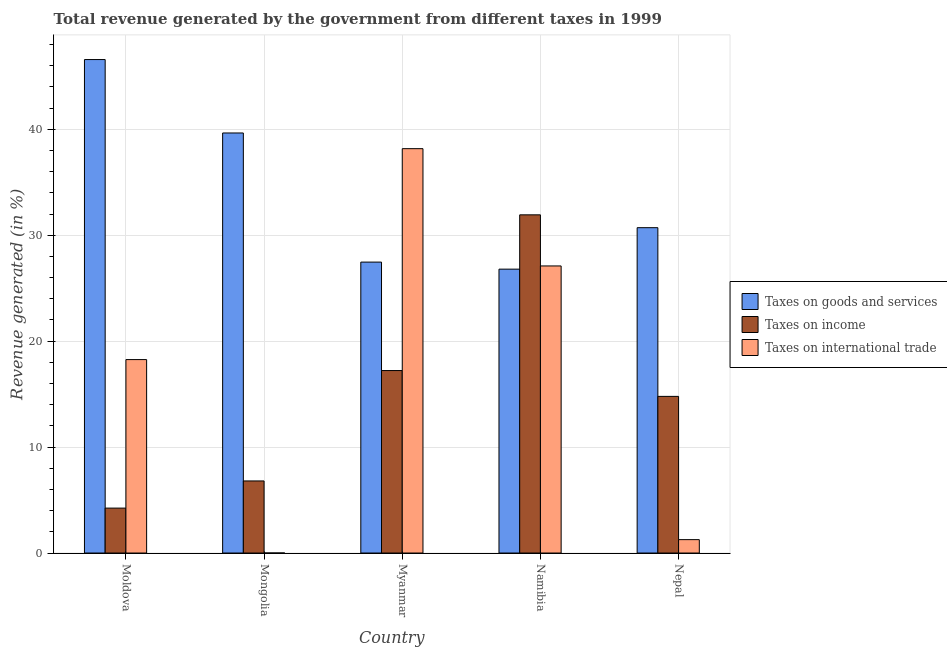How many different coloured bars are there?
Make the answer very short. 3. How many groups of bars are there?
Give a very brief answer. 5. How many bars are there on the 3rd tick from the left?
Your answer should be compact. 3. How many bars are there on the 2nd tick from the right?
Provide a short and direct response. 3. What is the label of the 1st group of bars from the left?
Provide a short and direct response. Moldova. In how many cases, is the number of bars for a given country not equal to the number of legend labels?
Your answer should be very brief. 0. What is the percentage of revenue generated by tax on international trade in Namibia?
Your response must be concise. 27.1. Across all countries, what is the maximum percentage of revenue generated by taxes on goods and services?
Provide a succinct answer. 46.58. Across all countries, what is the minimum percentage of revenue generated by tax on international trade?
Your response must be concise. 0. In which country was the percentage of revenue generated by taxes on goods and services maximum?
Give a very brief answer. Moldova. In which country was the percentage of revenue generated by tax on international trade minimum?
Provide a short and direct response. Mongolia. What is the total percentage of revenue generated by taxes on goods and services in the graph?
Provide a succinct answer. 171.19. What is the difference between the percentage of revenue generated by taxes on income in Mongolia and that in Myanmar?
Offer a very short reply. -10.42. What is the difference between the percentage of revenue generated by taxes on income in Moldova and the percentage of revenue generated by taxes on goods and services in Mongolia?
Give a very brief answer. -35.41. What is the average percentage of revenue generated by tax on international trade per country?
Offer a terse response. 16.96. What is the difference between the percentage of revenue generated by tax on international trade and percentage of revenue generated by taxes on income in Namibia?
Keep it short and to the point. -4.82. What is the ratio of the percentage of revenue generated by tax on international trade in Mongolia to that in Nepal?
Your response must be concise. 0. Is the percentage of revenue generated by tax on international trade in Namibia less than that in Nepal?
Your answer should be compact. No. What is the difference between the highest and the second highest percentage of revenue generated by tax on international trade?
Your answer should be compact. 11.07. What is the difference between the highest and the lowest percentage of revenue generated by taxes on income?
Offer a very short reply. 27.68. Is the sum of the percentage of revenue generated by taxes on income in Myanmar and Namibia greater than the maximum percentage of revenue generated by tax on international trade across all countries?
Ensure brevity in your answer.  Yes. What does the 1st bar from the left in Moldova represents?
Offer a terse response. Taxes on goods and services. What does the 2nd bar from the right in Myanmar represents?
Your answer should be very brief. Taxes on income. Is it the case that in every country, the sum of the percentage of revenue generated by taxes on goods and services and percentage of revenue generated by taxes on income is greater than the percentage of revenue generated by tax on international trade?
Ensure brevity in your answer.  Yes. How many countries are there in the graph?
Ensure brevity in your answer.  5. What is the difference between two consecutive major ticks on the Y-axis?
Provide a short and direct response. 10. Does the graph contain grids?
Your response must be concise. Yes. What is the title of the graph?
Keep it short and to the point. Total revenue generated by the government from different taxes in 1999. Does "Food" appear as one of the legend labels in the graph?
Provide a succinct answer. No. What is the label or title of the Y-axis?
Give a very brief answer. Revenue generated (in %). What is the Revenue generated (in %) of Taxes on goods and services in Moldova?
Make the answer very short. 46.58. What is the Revenue generated (in %) in Taxes on income in Moldova?
Offer a very short reply. 4.24. What is the Revenue generated (in %) in Taxes on international trade in Moldova?
Offer a very short reply. 18.26. What is the Revenue generated (in %) in Taxes on goods and services in Mongolia?
Provide a succinct answer. 39.65. What is the Revenue generated (in %) of Taxes on income in Mongolia?
Provide a succinct answer. 6.8. What is the Revenue generated (in %) in Taxes on international trade in Mongolia?
Provide a succinct answer. 0. What is the Revenue generated (in %) in Taxes on goods and services in Myanmar?
Keep it short and to the point. 27.46. What is the Revenue generated (in %) of Taxes on income in Myanmar?
Give a very brief answer. 17.22. What is the Revenue generated (in %) in Taxes on international trade in Myanmar?
Your response must be concise. 38.17. What is the Revenue generated (in %) of Taxes on goods and services in Namibia?
Make the answer very short. 26.8. What is the Revenue generated (in %) of Taxes on income in Namibia?
Offer a very short reply. 31.92. What is the Revenue generated (in %) in Taxes on international trade in Namibia?
Offer a terse response. 27.1. What is the Revenue generated (in %) in Taxes on goods and services in Nepal?
Make the answer very short. 30.71. What is the Revenue generated (in %) of Taxes on income in Nepal?
Provide a succinct answer. 14.79. What is the Revenue generated (in %) of Taxes on international trade in Nepal?
Make the answer very short. 1.26. Across all countries, what is the maximum Revenue generated (in %) of Taxes on goods and services?
Your response must be concise. 46.58. Across all countries, what is the maximum Revenue generated (in %) in Taxes on income?
Your answer should be very brief. 31.92. Across all countries, what is the maximum Revenue generated (in %) in Taxes on international trade?
Your answer should be very brief. 38.17. Across all countries, what is the minimum Revenue generated (in %) of Taxes on goods and services?
Keep it short and to the point. 26.8. Across all countries, what is the minimum Revenue generated (in %) of Taxes on income?
Offer a terse response. 4.24. Across all countries, what is the minimum Revenue generated (in %) in Taxes on international trade?
Provide a succinct answer. 0. What is the total Revenue generated (in %) of Taxes on goods and services in the graph?
Your answer should be compact. 171.19. What is the total Revenue generated (in %) in Taxes on income in the graph?
Offer a very short reply. 74.98. What is the total Revenue generated (in %) in Taxes on international trade in the graph?
Your answer should be compact. 84.79. What is the difference between the Revenue generated (in %) of Taxes on goods and services in Moldova and that in Mongolia?
Offer a terse response. 6.93. What is the difference between the Revenue generated (in %) of Taxes on income in Moldova and that in Mongolia?
Your response must be concise. -2.56. What is the difference between the Revenue generated (in %) of Taxes on international trade in Moldova and that in Mongolia?
Ensure brevity in your answer.  18.26. What is the difference between the Revenue generated (in %) in Taxes on goods and services in Moldova and that in Myanmar?
Provide a succinct answer. 19.12. What is the difference between the Revenue generated (in %) in Taxes on income in Moldova and that in Myanmar?
Offer a very short reply. -12.98. What is the difference between the Revenue generated (in %) in Taxes on international trade in Moldova and that in Myanmar?
Your response must be concise. -19.91. What is the difference between the Revenue generated (in %) in Taxes on goods and services in Moldova and that in Namibia?
Your answer should be compact. 19.78. What is the difference between the Revenue generated (in %) of Taxes on income in Moldova and that in Namibia?
Offer a terse response. -27.68. What is the difference between the Revenue generated (in %) of Taxes on international trade in Moldova and that in Namibia?
Your answer should be compact. -8.84. What is the difference between the Revenue generated (in %) of Taxes on goods and services in Moldova and that in Nepal?
Make the answer very short. 15.87. What is the difference between the Revenue generated (in %) in Taxes on income in Moldova and that in Nepal?
Your response must be concise. -10.55. What is the difference between the Revenue generated (in %) in Taxes on international trade in Moldova and that in Nepal?
Your answer should be compact. 16.99. What is the difference between the Revenue generated (in %) of Taxes on goods and services in Mongolia and that in Myanmar?
Offer a terse response. 12.19. What is the difference between the Revenue generated (in %) of Taxes on income in Mongolia and that in Myanmar?
Offer a terse response. -10.42. What is the difference between the Revenue generated (in %) in Taxes on international trade in Mongolia and that in Myanmar?
Provide a short and direct response. -38.17. What is the difference between the Revenue generated (in %) of Taxes on goods and services in Mongolia and that in Namibia?
Offer a very short reply. 12.85. What is the difference between the Revenue generated (in %) in Taxes on income in Mongolia and that in Namibia?
Keep it short and to the point. -25.12. What is the difference between the Revenue generated (in %) of Taxes on international trade in Mongolia and that in Namibia?
Your response must be concise. -27.1. What is the difference between the Revenue generated (in %) in Taxes on goods and services in Mongolia and that in Nepal?
Give a very brief answer. 8.94. What is the difference between the Revenue generated (in %) in Taxes on income in Mongolia and that in Nepal?
Your answer should be compact. -7.98. What is the difference between the Revenue generated (in %) of Taxes on international trade in Mongolia and that in Nepal?
Your response must be concise. -1.26. What is the difference between the Revenue generated (in %) in Taxes on goods and services in Myanmar and that in Namibia?
Offer a very short reply. 0.66. What is the difference between the Revenue generated (in %) of Taxes on income in Myanmar and that in Namibia?
Offer a very short reply. -14.7. What is the difference between the Revenue generated (in %) in Taxes on international trade in Myanmar and that in Namibia?
Your answer should be compact. 11.07. What is the difference between the Revenue generated (in %) of Taxes on goods and services in Myanmar and that in Nepal?
Your answer should be very brief. -3.25. What is the difference between the Revenue generated (in %) of Taxes on income in Myanmar and that in Nepal?
Keep it short and to the point. 2.44. What is the difference between the Revenue generated (in %) in Taxes on international trade in Myanmar and that in Nepal?
Your answer should be very brief. 36.9. What is the difference between the Revenue generated (in %) of Taxes on goods and services in Namibia and that in Nepal?
Keep it short and to the point. -3.91. What is the difference between the Revenue generated (in %) in Taxes on income in Namibia and that in Nepal?
Ensure brevity in your answer.  17.14. What is the difference between the Revenue generated (in %) in Taxes on international trade in Namibia and that in Nepal?
Your answer should be very brief. 25.83. What is the difference between the Revenue generated (in %) in Taxes on goods and services in Moldova and the Revenue generated (in %) in Taxes on income in Mongolia?
Offer a terse response. 39.78. What is the difference between the Revenue generated (in %) in Taxes on goods and services in Moldova and the Revenue generated (in %) in Taxes on international trade in Mongolia?
Offer a very short reply. 46.58. What is the difference between the Revenue generated (in %) in Taxes on income in Moldova and the Revenue generated (in %) in Taxes on international trade in Mongolia?
Your answer should be compact. 4.24. What is the difference between the Revenue generated (in %) of Taxes on goods and services in Moldova and the Revenue generated (in %) of Taxes on income in Myanmar?
Offer a terse response. 29.36. What is the difference between the Revenue generated (in %) of Taxes on goods and services in Moldova and the Revenue generated (in %) of Taxes on international trade in Myanmar?
Make the answer very short. 8.41. What is the difference between the Revenue generated (in %) of Taxes on income in Moldova and the Revenue generated (in %) of Taxes on international trade in Myanmar?
Give a very brief answer. -33.93. What is the difference between the Revenue generated (in %) in Taxes on goods and services in Moldova and the Revenue generated (in %) in Taxes on income in Namibia?
Make the answer very short. 14.66. What is the difference between the Revenue generated (in %) of Taxes on goods and services in Moldova and the Revenue generated (in %) of Taxes on international trade in Namibia?
Offer a very short reply. 19.48. What is the difference between the Revenue generated (in %) of Taxes on income in Moldova and the Revenue generated (in %) of Taxes on international trade in Namibia?
Provide a succinct answer. -22.86. What is the difference between the Revenue generated (in %) of Taxes on goods and services in Moldova and the Revenue generated (in %) of Taxes on income in Nepal?
Keep it short and to the point. 31.79. What is the difference between the Revenue generated (in %) of Taxes on goods and services in Moldova and the Revenue generated (in %) of Taxes on international trade in Nepal?
Provide a succinct answer. 45.32. What is the difference between the Revenue generated (in %) of Taxes on income in Moldova and the Revenue generated (in %) of Taxes on international trade in Nepal?
Provide a short and direct response. 2.98. What is the difference between the Revenue generated (in %) in Taxes on goods and services in Mongolia and the Revenue generated (in %) in Taxes on income in Myanmar?
Your answer should be very brief. 22.43. What is the difference between the Revenue generated (in %) of Taxes on goods and services in Mongolia and the Revenue generated (in %) of Taxes on international trade in Myanmar?
Ensure brevity in your answer.  1.48. What is the difference between the Revenue generated (in %) of Taxes on income in Mongolia and the Revenue generated (in %) of Taxes on international trade in Myanmar?
Provide a short and direct response. -31.36. What is the difference between the Revenue generated (in %) in Taxes on goods and services in Mongolia and the Revenue generated (in %) in Taxes on income in Namibia?
Offer a very short reply. 7.73. What is the difference between the Revenue generated (in %) in Taxes on goods and services in Mongolia and the Revenue generated (in %) in Taxes on international trade in Namibia?
Your response must be concise. 12.55. What is the difference between the Revenue generated (in %) of Taxes on income in Mongolia and the Revenue generated (in %) of Taxes on international trade in Namibia?
Give a very brief answer. -20.29. What is the difference between the Revenue generated (in %) of Taxes on goods and services in Mongolia and the Revenue generated (in %) of Taxes on income in Nepal?
Your answer should be compact. 24.86. What is the difference between the Revenue generated (in %) of Taxes on goods and services in Mongolia and the Revenue generated (in %) of Taxes on international trade in Nepal?
Keep it short and to the point. 38.38. What is the difference between the Revenue generated (in %) in Taxes on income in Mongolia and the Revenue generated (in %) in Taxes on international trade in Nepal?
Provide a succinct answer. 5.54. What is the difference between the Revenue generated (in %) in Taxes on goods and services in Myanmar and the Revenue generated (in %) in Taxes on income in Namibia?
Offer a very short reply. -4.46. What is the difference between the Revenue generated (in %) in Taxes on goods and services in Myanmar and the Revenue generated (in %) in Taxes on international trade in Namibia?
Your response must be concise. 0.36. What is the difference between the Revenue generated (in %) of Taxes on income in Myanmar and the Revenue generated (in %) of Taxes on international trade in Namibia?
Ensure brevity in your answer.  -9.87. What is the difference between the Revenue generated (in %) in Taxes on goods and services in Myanmar and the Revenue generated (in %) in Taxes on income in Nepal?
Keep it short and to the point. 12.67. What is the difference between the Revenue generated (in %) in Taxes on goods and services in Myanmar and the Revenue generated (in %) in Taxes on international trade in Nepal?
Your answer should be compact. 26.2. What is the difference between the Revenue generated (in %) of Taxes on income in Myanmar and the Revenue generated (in %) of Taxes on international trade in Nepal?
Your answer should be very brief. 15.96. What is the difference between the Revenue generated (in %) of Taxes on goods and services in Namibia and the Revenue generated (in %) of Taxes on income in Nepal?
Your answer should be compact. 12.01. What is the difference between the Revenue generated (in %) of Taxes on goods and services in Namibia and the Revenue generated (in %) of Taxes on international trade in Nepal?
Make the answer very short. 25.53. What is the difference between the Revenue generated (in %) in Taxes on income in Namibia and the Revenue generated (in %) in Taxes on international trade in Nepal?
Your response must be concise. 30.66. What is the average Revenue generated (in %) in Taxes on goods and services per country?
Your response must be concise. 34.24. What is the average Revenue generated (in %) in Taxes on income per country?
Provide a succinct answer. 15. What is the average Revenue generated (in %) in Taxes on international trade per country?
Offer a terse response. 16.96. What is the difference between the Revenue generated (in %) of Taxes on goods and services and Revenue generated (in %) of Taxes on income in Moldova?
Ensure brevity in your answer.  42.34. What is the difference between the Revenue generated (in %) in Taxes on goods and services and Revenue generated (in %) in Taxes on international trade in Moldova?
Ensure brevity in your answer.  28.32. What is the difference between the Revenue generated (in %) of Taxes on income and Revenue generated (in %) of Taxes on international trade in Moldova?
Offer a very short reply. -14.02. What is the difference between the Revenue generated (in %) of Taxes on goods and services and Revenue generated (in %) of Taxes on income in Mongolia?
Your response must be concise. 32.85. What is the difference between the Revenue generated (in %) in Taxes on goods and services and Revenue generated (in %) in Taxes on international trade in Mongolia?
Your response must be concise. 39.65. What is the difference between the Revenue generated (in %) in Taxes on income and Revenue generated (in %) in Taxes on international trade in Mongolia?
Your response must be concise. 6.8. What is the difference between the Revenue generated (in %) of Taxes on goods and services and Revenue generated (in %) of Taxes on income in Myanmar?
Keep it short and to the point. 10.24. What is the difference between the Revenue generated (in %) in Taxes on goods and services and Revenue generated (in %) in Taxes on international trade in Myanmar?
Give a very brief answer. -10.71. What is the difference between the Revenue generated (in %) in Taxes on income and Revenue generated (in %) in Taxes on international trade in Myanmar?
Give a very brief answer. -20.94. What is the difference between the Revenue generated (in %) of Taxes on goods and services and Revenue generated (in %) of Taxes on income in Namibia?
Offer a terse response. -5.13. What is the difference between the Revenue generated (in %) in Taxes on goods and services and Revenue generated (in %) in Taxes on international trade in Namibia?
Offer a very short reply. -0.3. What is the difference between the Revenue generated (in %) in Taxes on income and Revenue generated (in %) in Taxes on international trade in Namibia?
Your answer should be compact. 4.82. What is the difference between the Revenue generated (in %) in Taxes on goods and services and Revenue generated (in %) in Taxes on income in Nepal?
Give a very brief answer. 15.92. What is the difference between the Revenue generated (in %) in Taxes on goods and services and Revenue generated (in %) in Taxes on international trade in Nepal?
Your answer should be compact. 29.44. What is the difference between the Revenue generated (in %) in Taxes on income and Revenue generated (in %) in Taxes on international trade in Nepal?
Your response must be concise. 13.52. What is the ratio of the Revenue generated (in %) of Taxes on goods and services in Moldova to that in Mongolia?
Provide a short and direct response. 1.17. What is the ratio of the Revenue generated (in %) in Taxes on income in Moldova to that in Mongolia?
Offer a terse response. 0.62. What is the ratio of the Revenue generated (in %) of Taxes on international trade in Moldova to that in Mongolia?
Your response must be concise. 1.41e+04. What is the ratio of the Revenue generated (in %) in Taxes on goods and services in Moldova to that in Myanmar?
Your answer should be very brief. 1.7. What is the ratio of the Revenue generated (in %) in Taxes on income in Moldova to that in Myanmar?
Make the answer very short. 0.25. What is the ratio of the Revenue generated (in %) in Taxes on international trade in Moldova to that in Myanmar?
Ensure brevity in your answer.  0.48. What is the ratio of the Revenue generated (in %) of Taxes on goods and services in Moldova to that in Namibia?
Make the answer very short. 1.74. What is the ratio of the Revenue generated (in %) of Taxes on income in Moldova to that in Namibia?
Your response must be concise. 0.13. What is the ratio of the Revenue generated (in %) in Taxes on international trade in Moldova to that in Namibia?
Provide a short and direct response. 0.67. What is the ratio of the Revenue generated (in %) of Taxes on goods and services in Moldova to that in Nepal?
Give a very brief answer. 1.52. What is the ratio of the Revenue generated (in %) in Taxes on income in Moldova to that in Nepal?
Provide a short and direct response. 0.29. What is the ratio of the Revenue generated (in %) in Taxes on international trade in Moldova to that in Nepal?
Make the answer very short. 14.44. What is the ratio of the Revenue generated (in %) in Taxes on goods and services in Mongolia to that in Myanmar?
Your answer should be very brief. 1.44. What is the ratio of the Revenue generated (in %) of Taxes on income in Mongolia to that in Myanmar?
Offer a very short reply. 0.4. What is the ratio of the Revenue generated (in %) of Taxes on international trade in Mongolia to that in Myanmar?
Offer a terse response. 0. What is the ratio of the Revenue generated (in %) in Taxes on goods and services in Mongolia to that in Namibia?
Your answer should be very brief. 1.48. What is the ratio of the Revenue generated (in %) of Taxes on income in Mongolia to that in Namibia?
Provide a succinct answer. 0.21. What is the ratio of the Revenue generated (in %) in Taxes on goods and services in Mongolia to that in Nepal?
Keep it short and to the point. 1.29. What is the ratio of the Revenue generated (in %) of Taxes on income in Mongolia to that in Nepal?
Provide a succinct answer. 0.46. What is the ratio of the Revenue generated (in %) in Taxes on international trade in Mongolia to that in Nepal?
Your answer should be very brief. 0. What is the ratio of the Revenue generated (in %) of Taxes on goods and services in Myanmar to that in Namibia?
Provide a short and direct response. 1.02. What is the ratio of the Revenue generated (in %) of Taxes on income in Myanmar to that in Namibia?
Ensure brevity in your answer.  0.54. What is the ratio of the Revenue generated (in %) in Taxes on international trade in Myanmar to that in Namibia?
Offer a very short reply. 1.41. What is the ratio of the Revenue generated (in %) of Taxes on goods and services in Myanmar to that in Nepal?
Make the answer very short. 0.89. What is the ratio of the Revenue generated (in %) of Taxes on income in Myanmar to that in Nepal?
Give a very brief answer. 1.16. What is the ratio of the Revenue generated (in %) in Taxes on international trade in Myanmar to that in Nepal?
Offer a terse response. 30.18. What is the ratio of the Revenue generated (in %) in Taxes on goods and services in Namibia to that in Nepal?
Your answer should be compact. 0.87. What is the ratio of the Revenue generated (in %) in Taxes on income in Namibia to that in Nepal?
Make the answer very short. 2.16. What is the ratio of the Revenue generated (in %) in Taxes on international trade in Namibia to that in Nepal?
Give a very brief answer. 21.43. What is the difference between the highest and the second highest Revenue generated (in %) in Taxes on goods and services?
Your answer should be very brief. 6.93. What is the difference between the highest and the second highest Revenue generated (in %) in Taxes on income?
Ensure brevity in your answer.  14.7. What is the difference between the highest and the second highest Revenue generated (in %) in Taxes on international trade?
Offer a terse response. 11.07. What is the difference between the highest and the lowest Revenue generated (in %) in Taxes on goods and services?
Your response must be concise. 19.78. What is the difference between the highest and the lowest Revenue generated (in %) in Taxes on income?
Make the answer very short. 27.68. What is the difference between the highest and the lowest Revenue generated (in %) of Taxes on international trade?
Provide a short and direct response. 38.17. 